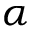Convert formula to latex. <formula><loc_0><loc_0><loc_500><loc_500>\alpha</formula> 